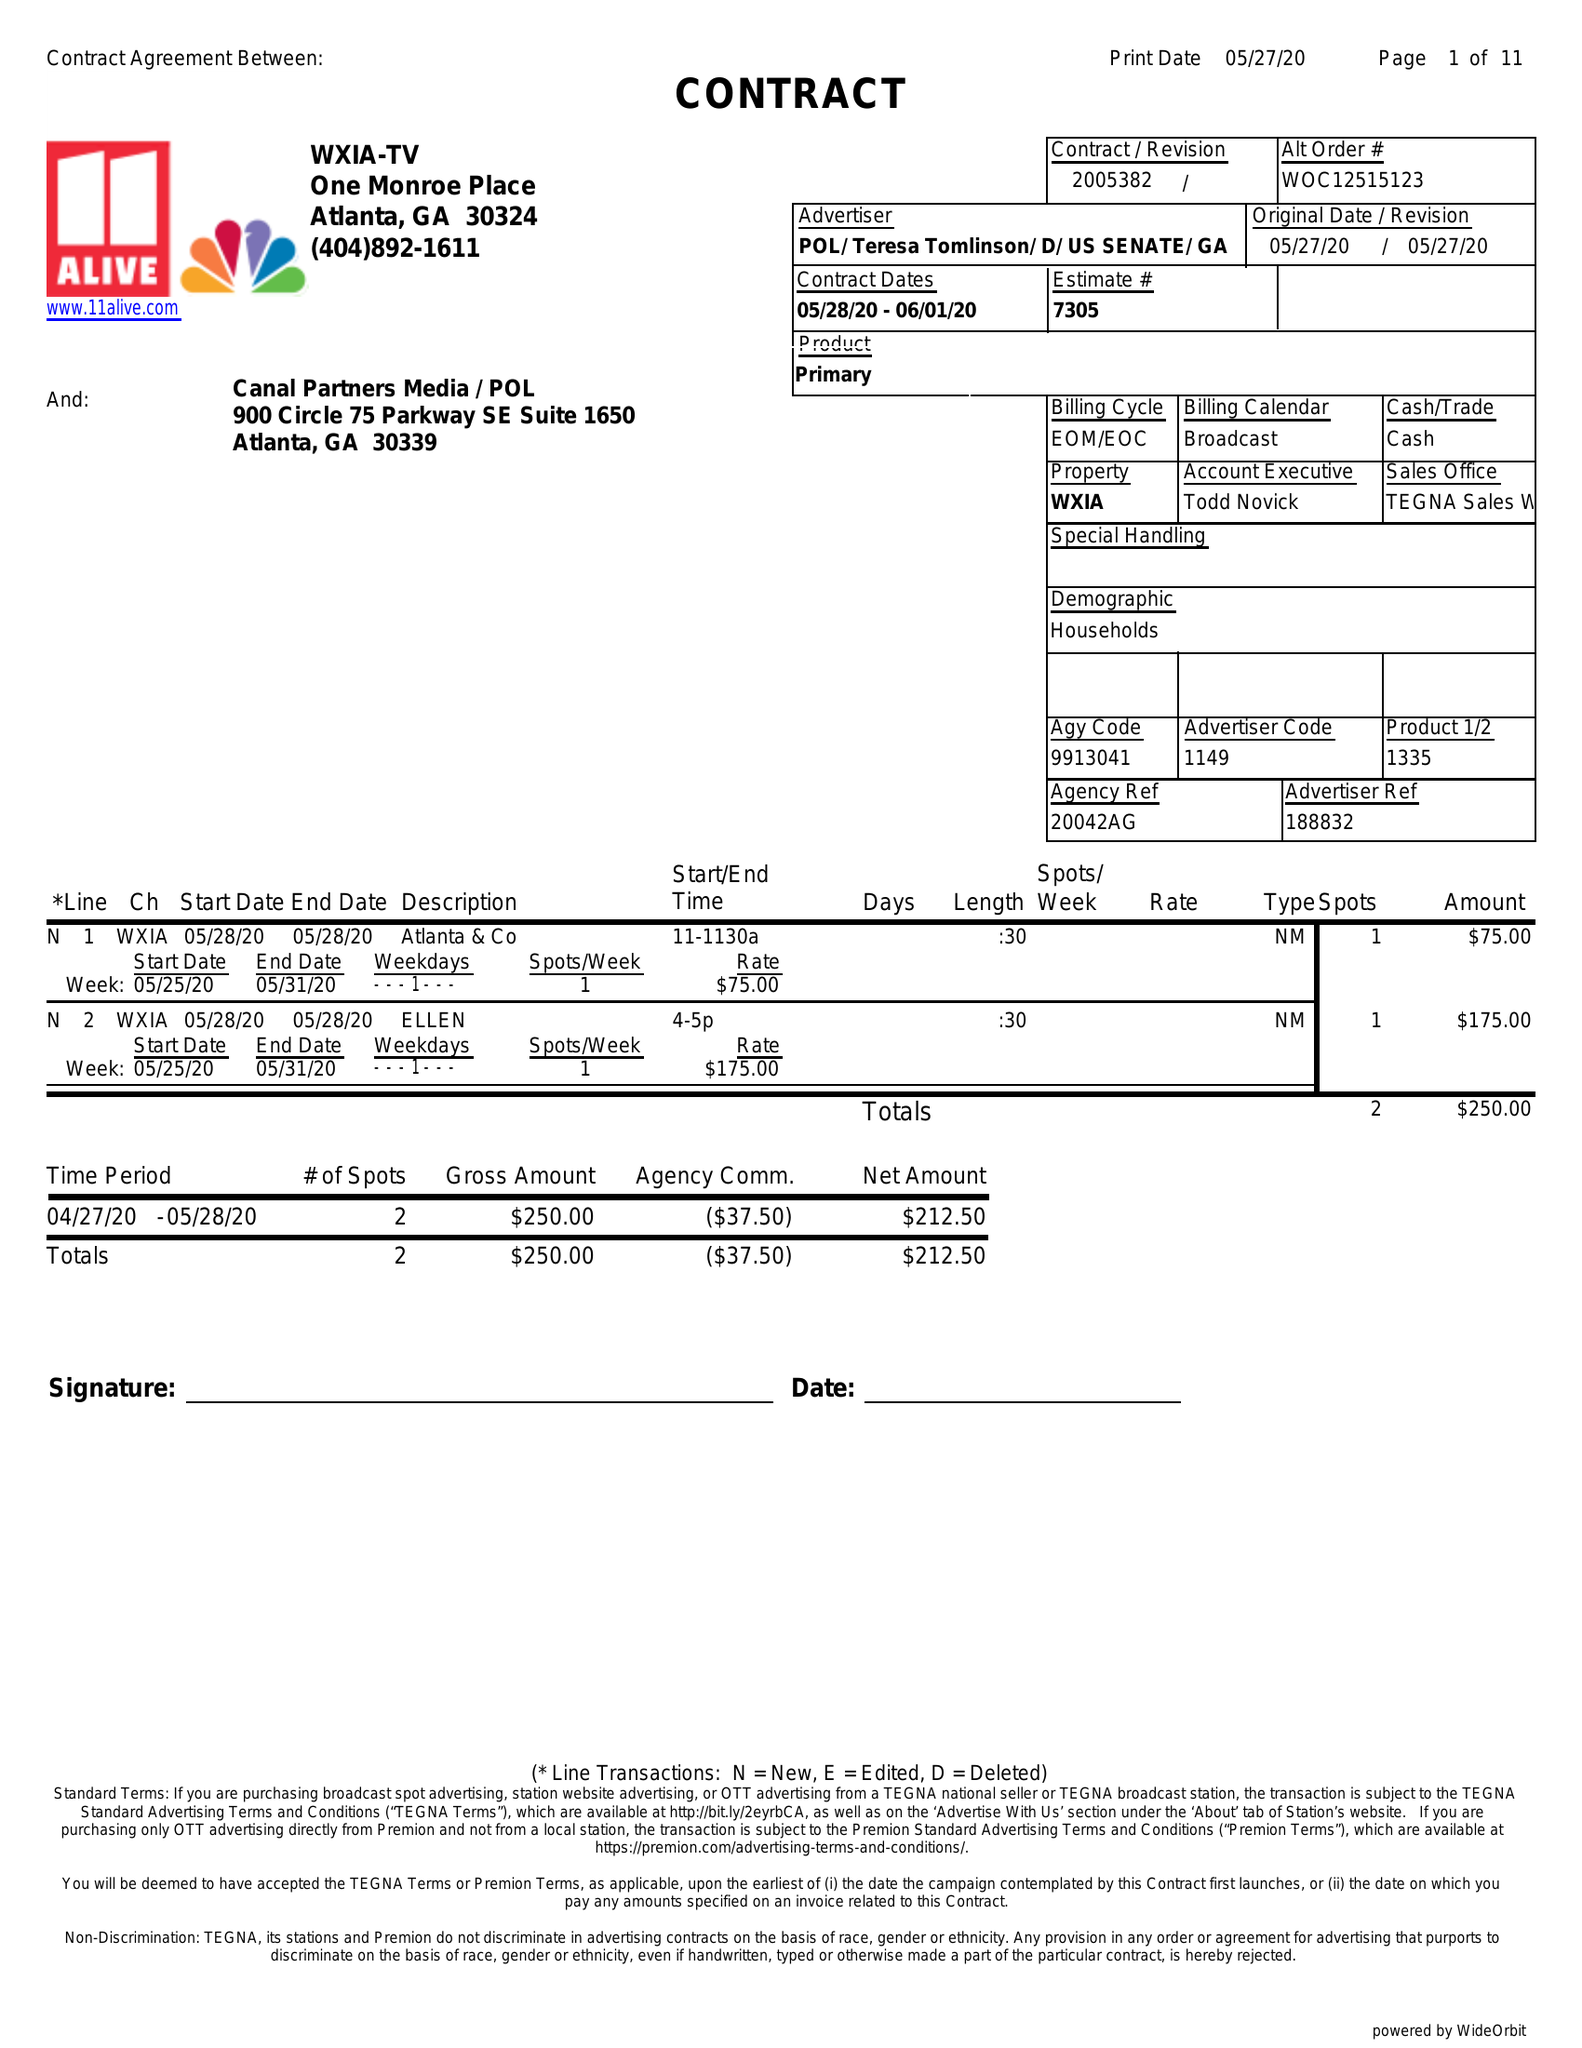What is the value for the contract_num?
Answer the question using a single word or phrase. 2005382 